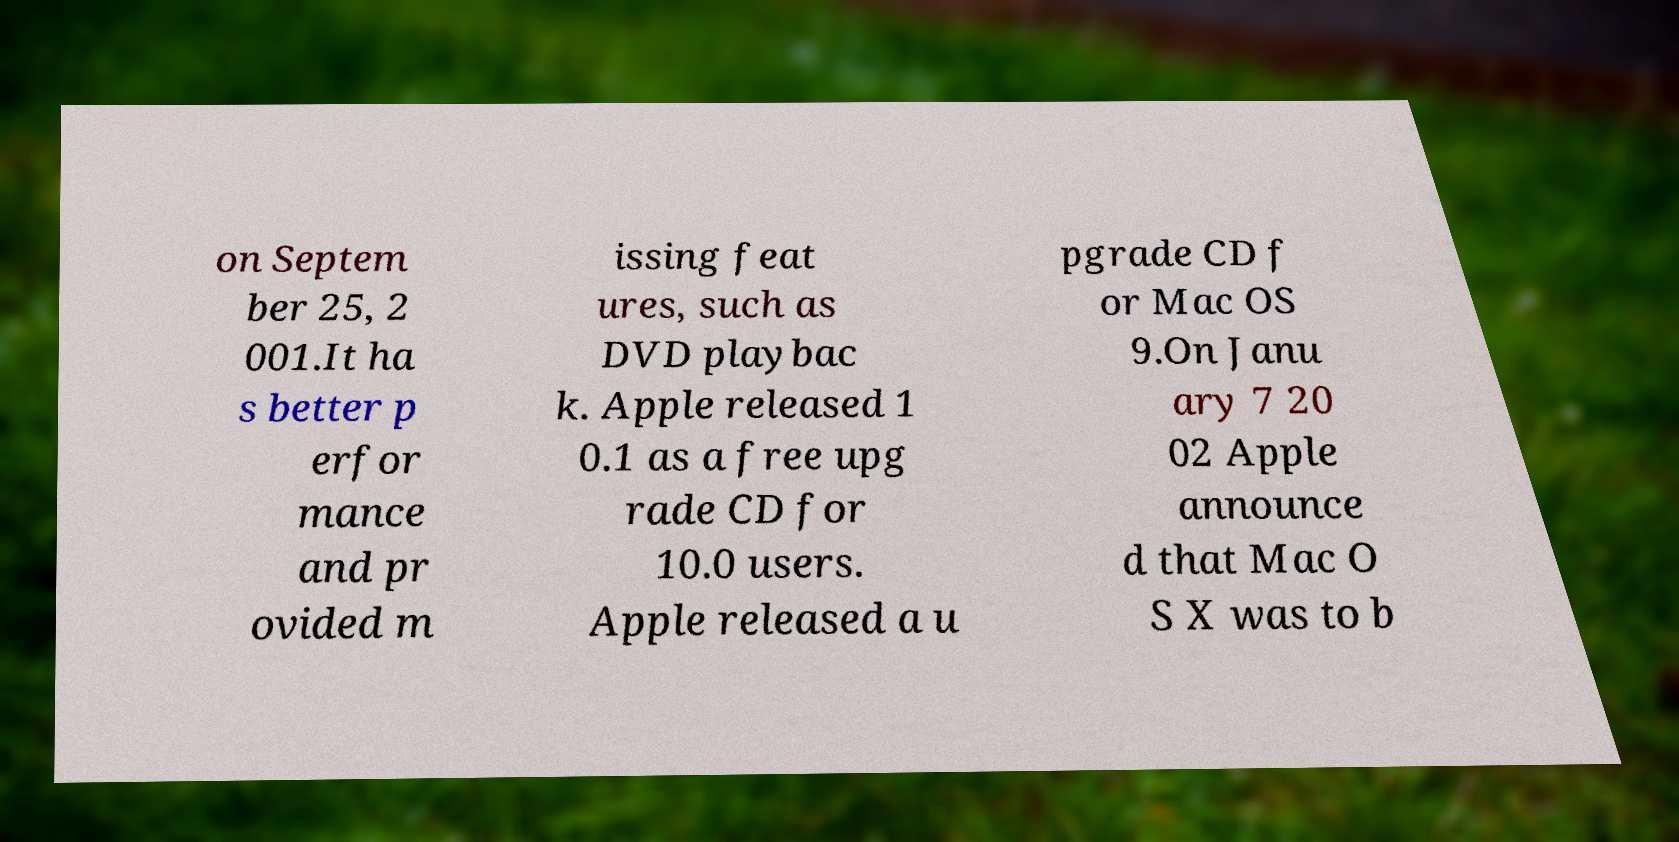Can you accurately transcribe the text from the provided image for me? on Septem ber 25, 2 001.It ha s better p erfor mance and pr ovided m issing feat ures, such as DVD playbac k. Apple released 1 0.1 as a free upg rade CD for 10.0 users. Apple released a u pgrade CD f or Mac OS 9.On Janu ary 7 20 02 Apple announce d that Mac O S X was to b 